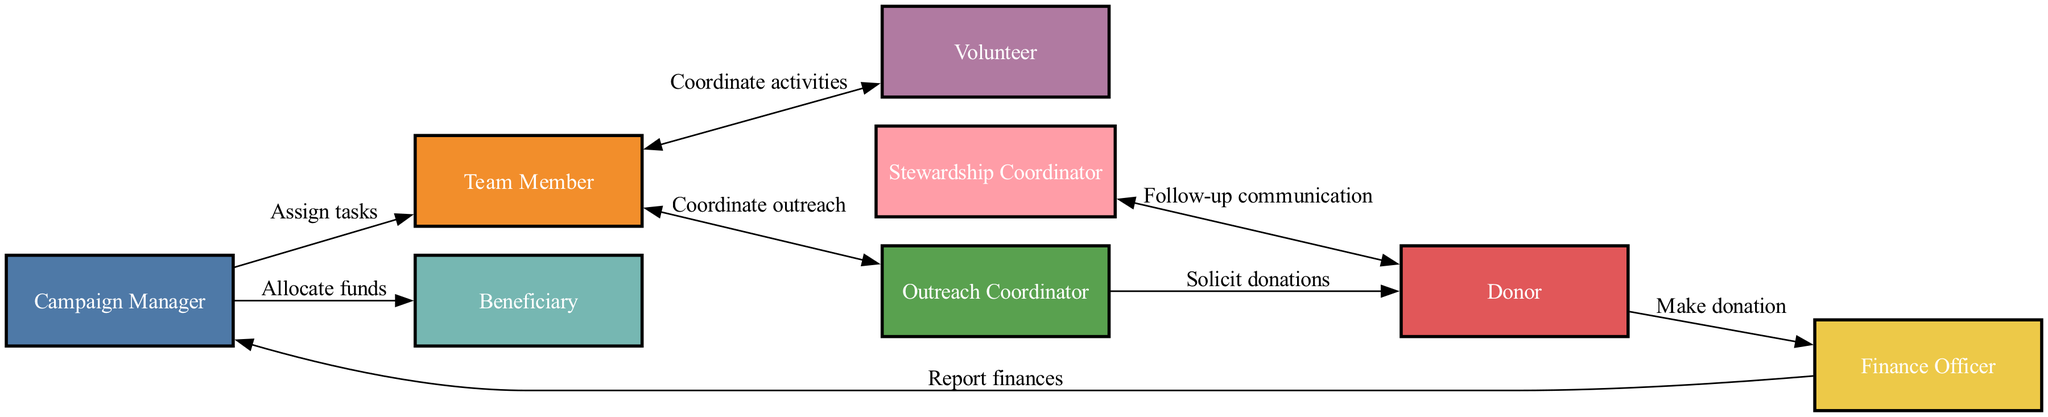What is the role of the Campaign Manager? The Campaign Manager oversees the entire fundraising campaign and coordinates team members, as indicated in the diagram.
Answer: Responsible for overseeing the entire fundraising campaign How many nodes are in the diagram? The diagram contains nodes representing each element involved in the fundraising campaign. Counting the nodes gives us a total of eight: Campaign Manager, Team Member, Donor, Beneficiary, Outreach Coordinator, Finance Officer, Volunteer, and Stewardship Coordinator.
Answer: 8 Who does the Outreach Coordinator communicate with? The Outreach Coordinator solicits donations from the Donor, as shown by the directional edge connecting these two nodes in the diagram.
Answer: Donor What is the flow of funds from the Donor? The Donor makes a donation to the Finance Officer, who then reports finances to the Campaign Manager. This sequence indicates the flow of funds in the campaign.
Answer: Donor to Finance Officer to Campaign Manager Who coordinates activities with Volunteers? The Team Member coordinates activities with Volunteers, as depicted in the mutual edge that connects these two nodes in the diagram.
Answer: Team Member What happens after a donation is made? After a donation is made by the Donor, the Finance Officer receives this information and is responsible for reporting finances back to the Campaign Manager.
Answer: Report finances What does the Stewardship Coordinator do? The Stewardship Coordinator follows up with donors through communication, maintaining relationships with them after their contributions, indicated in the diagram.
Answer: Follow-up communication What is the relationship between the Campaign Manager and the Beneficiary? The Campaign Manager allocates funds to the Beneficiary, showcasing a directional relationship where funds are directed towards the beneficiary of the campaign.
Answer: Allocate funds 